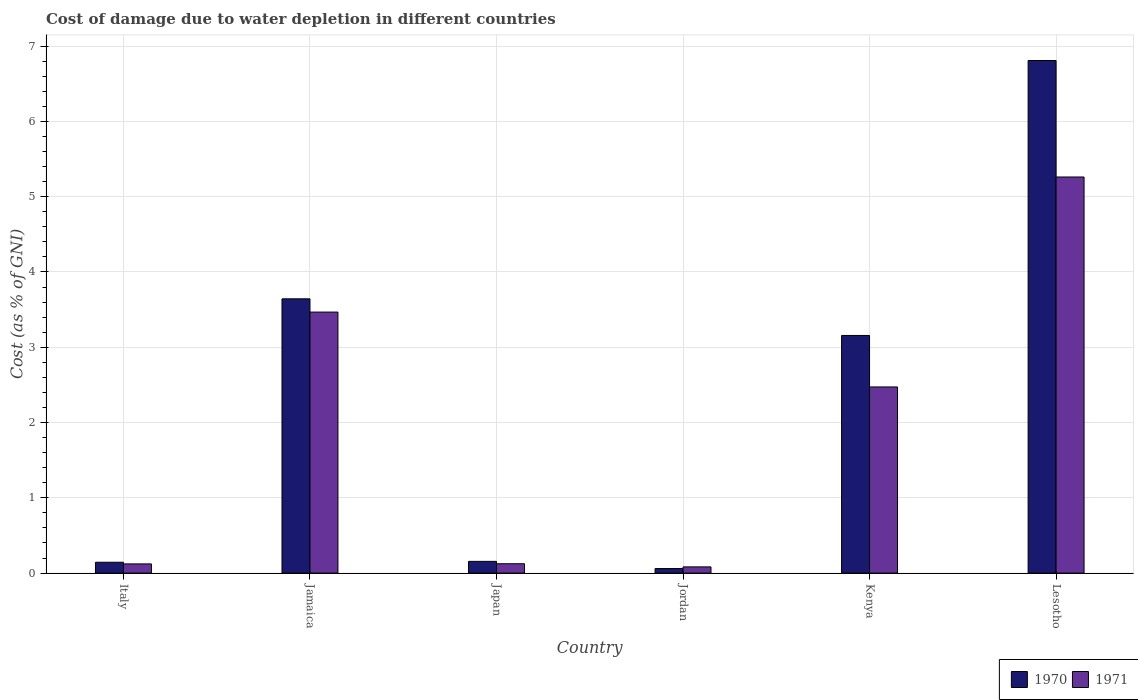How many different coloured bars are there?
Provide a short and direct response. 2. How many groups of bars are there?
Keep it short and to the point. 6. Are the number of bars per tick equal to the number of legend labels?
Give a very brief answer. Yes. Are the number of bars on each tick of the X-axis equal?
Make the answer very short. Yes. How many bars are there on the 4th tick from the left?
Your response must be concise. 2. What is the label of the 6th group of bars from the left?
Give a very brief answer. Lesotho. In how many cases, is the number of bars for a given country not equal to the number of legend labels?
Give a very brief answer. 0. What is the cost of damage caused due to water depletion in 1970 in Japan?
Your response must be concise. 0.16. Across all countries, what is the maximum cost of damage caused due to water depletion in 1970?
Keep it short and to the point. 6.81. Across all countries, what is the minimum cost of damage caused due to water depletion in 1970?
Your answer should be compact. 0.06. In which country was the cost of damage caused due to water depletion in 1971 maximum?
Offer a very short reply. Lesotho. In which country was the cost of damage caused due to water depletion in 1971 minimum?
Your response must be concise. Jordan. What is the total cost of damage caused due to water depletion in 1971 in the graph?
Ensure brevity in your answer.  11.53. What is the difference between the cost of damage caused due to water depletion in 1970 in Jordan and that in Kenya?
Your response must be concise. -3.1. What is the difference between the cost of damage caused due to water depletion in 1970 in Jordan and the cost of damage caused due to water depletion in 1971 in Japan?
Your answer should be very brief. -0.06. What is the average cost of damage caused due to water depletion in 1970 per country?
Keep it short and to the point. 2.33. What is the difference between the cost of damage caused due to water depletion of/in 1970 and cost of damage caused due to water depletion of/in 1971 in Jordan?
Offer a terse response. -0.02. What is the ratio of the cost of damage caused due to water depletion in 1971 in Japan to that in Jordan?
Your answer should be very brief. 1.51. What is the difference between the highest and the second highest cost of damage caused due to water depletion in 1971?
Keep it short and to the point. -0.99. What is the difference between the highest and the lowest cost of damage caused due to water depletion in 1971?
Provide a succinct answer. 5.18. Is the sum of the cost of damage caused due to water depletion in 1971 in Japan and Kenya greater than the maximum cost of damage caused due to water depletion in 1970 across all countries?
Offer a terse response. No. What does the 2nd bar from the left in Jordan represents?
Offer a terse response. 1971. Are all the bars in the graph horizontal?
Your answer should be very brief. No. How many countries are there in the graph?
Offer a terse response. 6. Does the graph contain grids?
Offer a terse response. Yes. How many legend labels are there?
Ensure brevity in your answer.  2. What is the title of the graph?
Your answer should be compact. Cost of damage due to water depletion in different countries. Does "1960" appear as one of the legend labels in the graph?
Offer a terse response. No. What is the label or title of the X-axis?
Your answer should be compact. Country. What is the label or title of the Y-axis?
Your response must be concise. Cost (as % of GNI). What is the Cost (as % of GNI) in 1970 in Italy?
Your answer should be very brief. 0.14. What is the Cost (as % of GNI) of 1971 in Italy?
Keep it short and to the point. 0.12. What is the Cost (as % of GNI) of 1970 in Jamaica?
Make the answer very short. 3.64. What is the Cost (as % of GNI) of 1971 in Jamaica?
Give a very brief answer. 3.47. What is the Cost (as % of GNI) of 1970 in Japan?
Your response must be concise. 0.16. What is the Cost (as % of GNI) of 1971 in Japan?
Provide a succinct answer. 0.12. What is the Cost (as % of GNI) in 1970 in Jordan?
Offer a very short reply. 0.06. What is the Cost (as % of GNI) in 1971 in Jordan?
Give a very brief answer. 0.08. What is the Cost (as % of GNI) in 1970 in Kenya?
Your response must be concise. 3.16. What is the Cost (as % of GNI) of 1971 in Kenya?
Provide a short and direct response. 2.47. What is the Cost (as % of GNI) in 1970 in Lesotho?
Make the answer very short. 6.81. What is the Cost (as % of GNI) of 1971 in Lesotho?
Provide a short and direct response. 5.26. Across all countries, what is the maximum Cost (as % of GNI) of 1970?
Provide a short and direct response. 6.81. Across all countries, what is the maximum Cost (as % of GNI) in 1971?
Make the answer very short. 5.26. Across all countries, what is the minimum Cost (as % of GNI) of 1970?
Make the answer very short. 0.06. Across all countries, what is the minimum Cost (as % of GNI) of 1971?
Give a very brief answer. 0.08. What is the total Cost (as % of GNI) of 1970 in the graph?
Provide a short and direct response. 13.97. What is the total Cost (as % of GNI) of 1971 in the graph?
Your answer should be compact. 11.53. What is the difference between the Cost (as % of GNI) in 1970 in Italy and that in Jamaica?
Make the answer very short. -3.5. What is the difference between the Cost (as % of GNI) in 1971 in Italy and that in Jamaica?
Make the answer very short. -3.35. What is the difference between the Cost (as % of GNI) in 1970 in Italy and that in Japan?
Offer a terse response. -0.01. What is the difference between the Cost (as % of GNI) of 1971 in Italy and that in Japan?
Your answer should be very brief. -0. What is the difference between the Cost (as % of GNI) of 1970 in Italy and that in Jordan?
Provide a succinct answer. 0.08. What is the difference between the Cost (as % of GNI) of 1971 in Italy and that in Jordan?
Make the answer very short. 0.04. What is the difference between the Cost (as % of GNI) in 1970 in Italy and that in Kenya?
Your answer should be very brief. -3.01. What is the difference between the Cost (as % of GNI) of 1971 in Italy and that in Kenya?
Offer a terse response. -2.35. What is the difference between the Cost (as % of GNI) of 1970 in Italy and that in Lesotho?
Provide a short and direct response. -6.67. What is the difference between the Cost (as % of GNI) of 1971 in Italy and that in Lesotho?
Ensure brevity in your answer.  -5.14. What is the difference between the Cost (as % of GNI) in 1970 in Jamaica and that in Japan?
Give a very brief answer. 3.49. What is the difference between the Cost (as % of GNI) of 1971 in Jamaica and that in Japan?
Your answer should be compact. 3.34. What is the difference between the Cost (as % of GNI) of 1970 in Jamaica and that in Jordan?
Your answer should be very brief. 3.58. What is the difference between the Cost (as % of GNI) in 1971 in Jamaica and that in Jordan?
Provide a short and direct response. 3.38. What is the difference between the Cost (as % of GNI) in 1970 in Jamaica and that in Kenya?
Ensure brevity in your answer.  0.49. What is the difference between the Cost (as % of GNI) in 1971 in Jamaica and that in Kenya?
Keep it short and to the point. 0.99. What is the difference between the Cost (as % of GNI) of 1970 in Jamaica and that in Lesotho?
Make the answer very short. -3.17. What is the difference between the Cost (as % of GNI) in 1971 in Jamaica and that in Lesotho?
Your answer should be compact. -1.79. What is the difference between the Cost (as % of GNI) in 1970 in Japan and that in Jordan?
Provide a short and direct response. 0.1. What is the difference between the Cost (as % of GNI) of 1971 in Japan and that in Jordan?
Ensure brevity in your answer.  0.04. What is the difference between the Cost (as % of GNI) in 1970 in Japan and that in Kenya?
Keep it short and to the point. -3. What is the difference between the Cost (as % of GNI) in 1971 in Japan and that in Kenya?
Your answer should be very brief. -2.35. What is the difference between the Cost (as % of GNI) in 1970 in Japan and that in Lesotho?
Your answer should be compact. -6.65. What is the difference between the Cost (as % of GNI) of 1971 in Japan and that in Lesotho?
Your response must be concise. -5.14. What is the difference between the Cost (as % of GNI) of 1970 in Jordan and that in Kenya?
Offer a very short reply. -3.1. What is the difference between the Cost (as % of GNI) of 1971 in Jordan and that in Kenya?
Make the answer very short. -2.39. What is the difference between the Cost (as % of GNI) in 1970 in Jordan and that in Lesotho?
Make the answer very short. -6.75. What is the difference between the Cost (as % of GNI) of 1971 in Jordan and that in Lesotho?
Provide a short and direct response. -5.18. What is the difference between the Cost (as % of GNI) in 1970 in Kenya and that in Lesotho?
Offer a terse response. -3.65. What is the difference between the Cost (as % of GNI) in 1971 in Kenya and that in Lesotho?
Make the answer very short. -2.79. What is the difference between the Cost (as % of GNI) of 1970 in Italy and the Cost (as % of GNI) of 1971 in Jamaica?
Your answer should be compact. -3.32. What is the difference between the Cost (as % of GNI) in 1970 in Italy and the Cost (as % of GNI) in 1971 in Japan?
Provide a short and direct response. 0.02. What is the difference between the Cost (as % of GNI) in 1970 in Italy and the Cost (as % of GNI) in 1971 in Jordan?
Provide a short and direct response. 0.06. What is the difference between the Cost (as % of GNI) of 1970 in Italy and the Cost (as % of GNI) of 1971 in Kenya?
Provide a succinct answer. -2.33. What is the difference between the Cost (as % of GNI) of 1970 in Italy and the Cost (as % of GNI) of 1971 in Lesotho?
Make the answer very short. -5.12. What is the difference between the Cost (as % of GNI) in 1970 in Jamaica and the Cost (as % of GNI) in 1971 in Japan?
Provide a succinct answer. 3.52. What is the difference between the Cost (as % of GNI) in 1970 in Jamaica and the Cost (as % of GNI) in 1971 in Jordan?
Give a very brief answer. 3.56. What is the difference between the Cost (as % of GNI) of 1970 in Jamaica and the Cost (as % of GNI) of 1971 in Kenya?
Offer a very short reply. 1.17. What is the difference between the Cost (as % of GNI) of 1970 in Jamaica and the Cost (as % of GNI) of 1971 in Lesotho?
Your response must be concise. -1.62. What is the difference between the Cost (as % of GNI) in 1970 in Japan and the Cost (as % of GNI) in 1971 in Jordan?
Make the answer very short. 0.07. What is the difference between the Cost (as % of GNI) of 1970 in Japan and the Cost (as % of GNI) of 1971 in Kenya?
Your answer should be very brief. -2.32. What is the difference between the Cost (as % of GNI) in 1970 in Japan and the Cost (as % of GNI) in 1971 in Lesotho?
Provide a succinct answer. -5.11. What is the difference between the Cost (as % of GNI) in 1970 in Jordan and the Cost (as % of GNI) in 1971 in Kenya?
Provide a succinct answer. -2.41. What is the difference between the Cost (as % of GNI) in 1970 in Jordan and the Cost (as % of GNI) in 1971 in Lesotho?
Make the answer very short. -5.2. What is the difference between the Cost (as % of GNI) in 1970 in Kenya and the Cost (as % of GNI) in 1971 in Lesotho?
Your answer should be compact. -2.1. What is the average Cost (as % of GNI) in 1970 per country?
Offer a terse response. 2.33. What is the average Cost (as % of GNI) of 1971 per country?
Your response must be concise. 1.92. What is the difference between the Cost (as % of GNI) in 1970 and Cost (as % of GNI) in 1971 in Italy?
Ensure brevity in your answer.  0.02. What is the difference between the Cost (as % of GNI) of 1970 and Cost (as % of GNI) of 1971 in Jamaica?
Ensure brevity in your answer.  0.18. What is the difference between the Cost (as % of GNI) in 1970 and Cost (as % of GNI) in 1971 in Japan?
Provide a short and direct response. 0.03. What is the difference between the Cost (as % of GNI) in 1970 and Cost (as % of GNI) in 1971 in Jordan?
Give a very brief answer. -0.02. What is the difference between the Cost (as % of GNI) of 1970 and Cost (as % of GNI) of 1971 in Kenya?
Your answer should be very brief. 0.68. What is the difference between the Cost (as % of GNI) of 1970 and Cost (as % of GNI) of 1971 in Lesotho?
Provide a succinct answer. 1.55. What is the ratio of the Cost (as % of GNI) in 1970 in Italy to that in Jamaica?
Offer a terse response. 0.04. What is the ratio of the Cost (as % of GNI) of 1971 in Italy to that in Jamaica?
Offer a terse response. 0.04. What is the ratio of the Cost (as % of GNI) in 1970 in Italy to that in Japan?
Provide a succinct answer. 0.93. What is the ratio of the Cost (as % of GNI) of 1971 in Italy to that in Japan?
Provide a succinct answer. 0.98. What is the ratio of the Cost (as % of GNI) of 1970 in Italy to that in Jordan?
Your response must be concise. 2.39. What is the ratio of the Cost (as % of GNI) of 1971 in Italy to that in Jordan?
Provide a succinct answer. 1.48. What is the ratio of the Cost (as % of GNI) in 1970 in Italy to that in Kenya?
Offer a terse response. 0.05. What is the ratio of the Cost (as % of GNI) of 1971 in Italy to that in Kenya?
Give a very brief answer. 0.05. What is the ratio of the Cost (as % of GNI) in 1970 in Italy to that in Lesotho?
Offer a very short reply. 0.02. What is the ratio of the Cost (as % of GNI) of 1971 in Italy to that in Lesotho?
Keep it short and to the point. 0.02. What is the ratio of the Cost (as % of GNI) in 1970 in Jamaica to that in Japan?
Offer a very short reply. 23.38. What is the ratio of the Cost (as % of GNI) of 1971 in Jamaica to that in Japan?
Provide a succinct answer. 27.88. What is the ratio of the Cost (as % of GNI) in 1970 in Jamaica to that in Jordan?
Ensure brevity in your answer.  60.35. What is the ratio of the Cost (as % of GNI) in 1971 in Jamaica to that in Jordan?
Your answer should be compact. 42.04. What is the ratio of the Cost (as % of GNI) in 1970 in Jamaica to that in Kenya?
Provide a succinct answer. 1.15. What is the ratio of the Cost (as % of GNI) in 1971 in Jamaica to that in Kenya?
Keep it short and to the point. 1.4. What is the ratio of the Cost (as % of GNI) of 1970 in Jamaica to that in Lesotho?
Provide a short and direct response. 0.54. What is the ratio of the Cost (as % of GNI) of 1971 in Jamaica to that in Lesotho?
Your response must be concise. 0.66. What is the ratio of the Cost (as % of GNI) of 1970 in Japan to that in Jordan?
Your answer should be compact. 2.58. What is the ratio of the Cost (as % of GNI) of 1971 in Japan to that in Jordan?
Offer a very short reply. 1.51. What is the ratio of the Cost (as % of GNI) of 1970 in Japan to that in Kenya?
Provide a succinct answer. 0.05. What is the ratio of the Cost (as % of GNI) of 1971 in Japan to that in Kenya?
Your answer should be compact. 0.05. What is the ratio of the Cost (as % of GNI) of 1970 in Japan to that in Lesotho?
Your answer should be very brief. 0.02. What is the ratio of the Cost (as % of GNI) of 1971 in Japan to that in Lesotho?
Keep it short and to the point. 0.02. What is the ratio of the Cost (as % of GNI) in 1970 in Jordan to that in Kenya?
Offer a very short reply. 0.02. What is the ratio of the Cost (as % of GNI) of 1971 in Jordan to that in Kenya?
Make the answer very short. 0.03. What is the ratio of the Cost (as % of GNI) of 1970 in Jordan to that in Lesotho?
Your response must be concise. 0.01. What is the ratio of the Cost (as % of GNI) in 1971 in Jordan to that in Lesotho?
Make the answer very short. 0.02. What is the ratio of the Cost (as % of GNI) in 1970 in Kenya to that in Lesotho?
Provide a succinct answer. 0.46. What is the ratio of the Cost (as % of GNI) in 1971 in Kenya to that in Lesotho?
Offer a terse response. 0.47. What is the difference between the highest and the second highest Cost (as % of GNI) in 1970?
Your answer should be compact. 3.17. What is the difference between the highest and the second highest Cost (as % of GNI) of 1971?
Make the answer very short. 1.79. What is the difference between the highest and the lowest Cost (as % of GNI) in 1970?
Make the answer very short. 6.75. What is the difference between the highest and the lowest Cost (as % of GNI) in 1971?
Offer a very short reply. 5.18. 